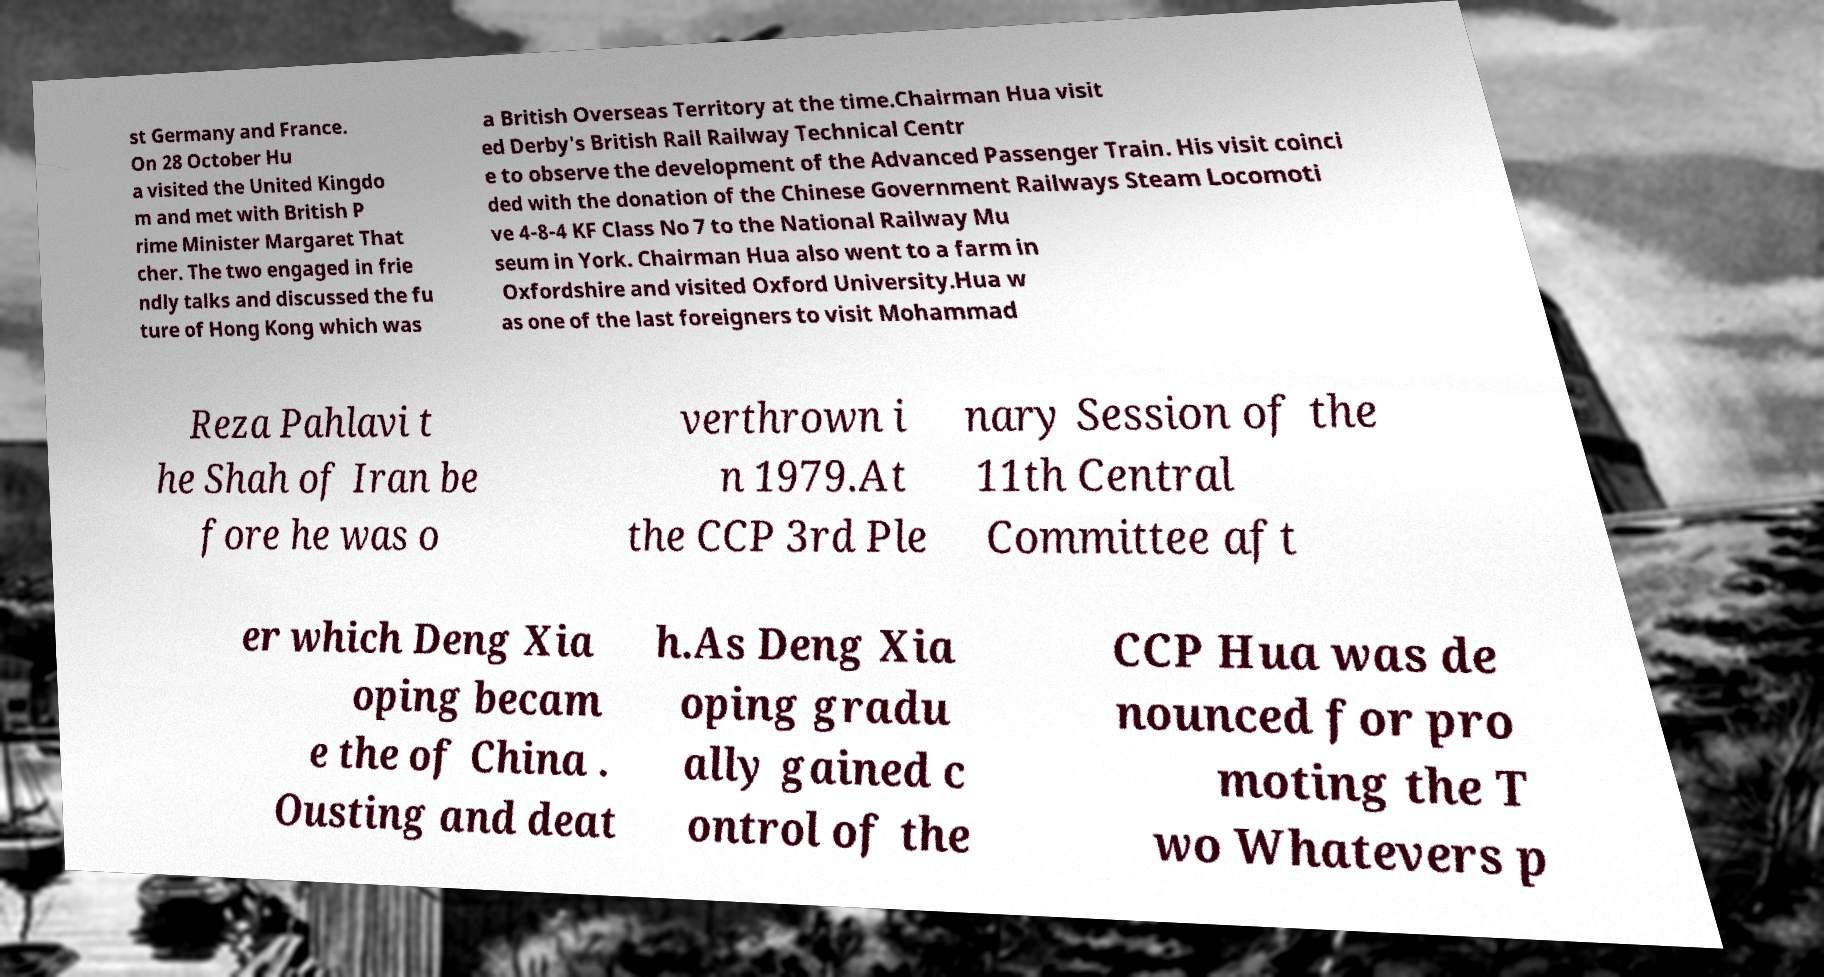I need the written content from this picture converted into text. Can you do that? st Germany and France. On 28 October Hu a visited the United Kingdo m and met with British P rime Minister Margaret That cher. The two engaged in frie ndly talks and discussed the fu ture of Hong Kong which was a British Overseas Territory at the time.Chairman Hua visit ed Derby's British Rail Railway Technical Centr e to observe the development of the Advanced Passenger Train. His visit coinci ded with the donation of the Chinese Government Railways Steam Locomoti ve 4-8-4 KF Class No 7 to the National Railway Mu seum in York. Chairman Hua also went to a farm in Oxfordshire and visited Oxford University.Hua w as one of the last foreigners to visit Mohammad Reza Pahlavi t he Shah of Iran be fore he was o verthrown i n 1979.At the CCP 3rd Ple nary Session of the 11th Central Committee aft er which Deng Xia oping becam e the of China . Ousting and deat h.As Deng Xia oping gradu ally gained c ontrol of the CCP Hua was de nounced for pro moting the T wo Whatevers p 